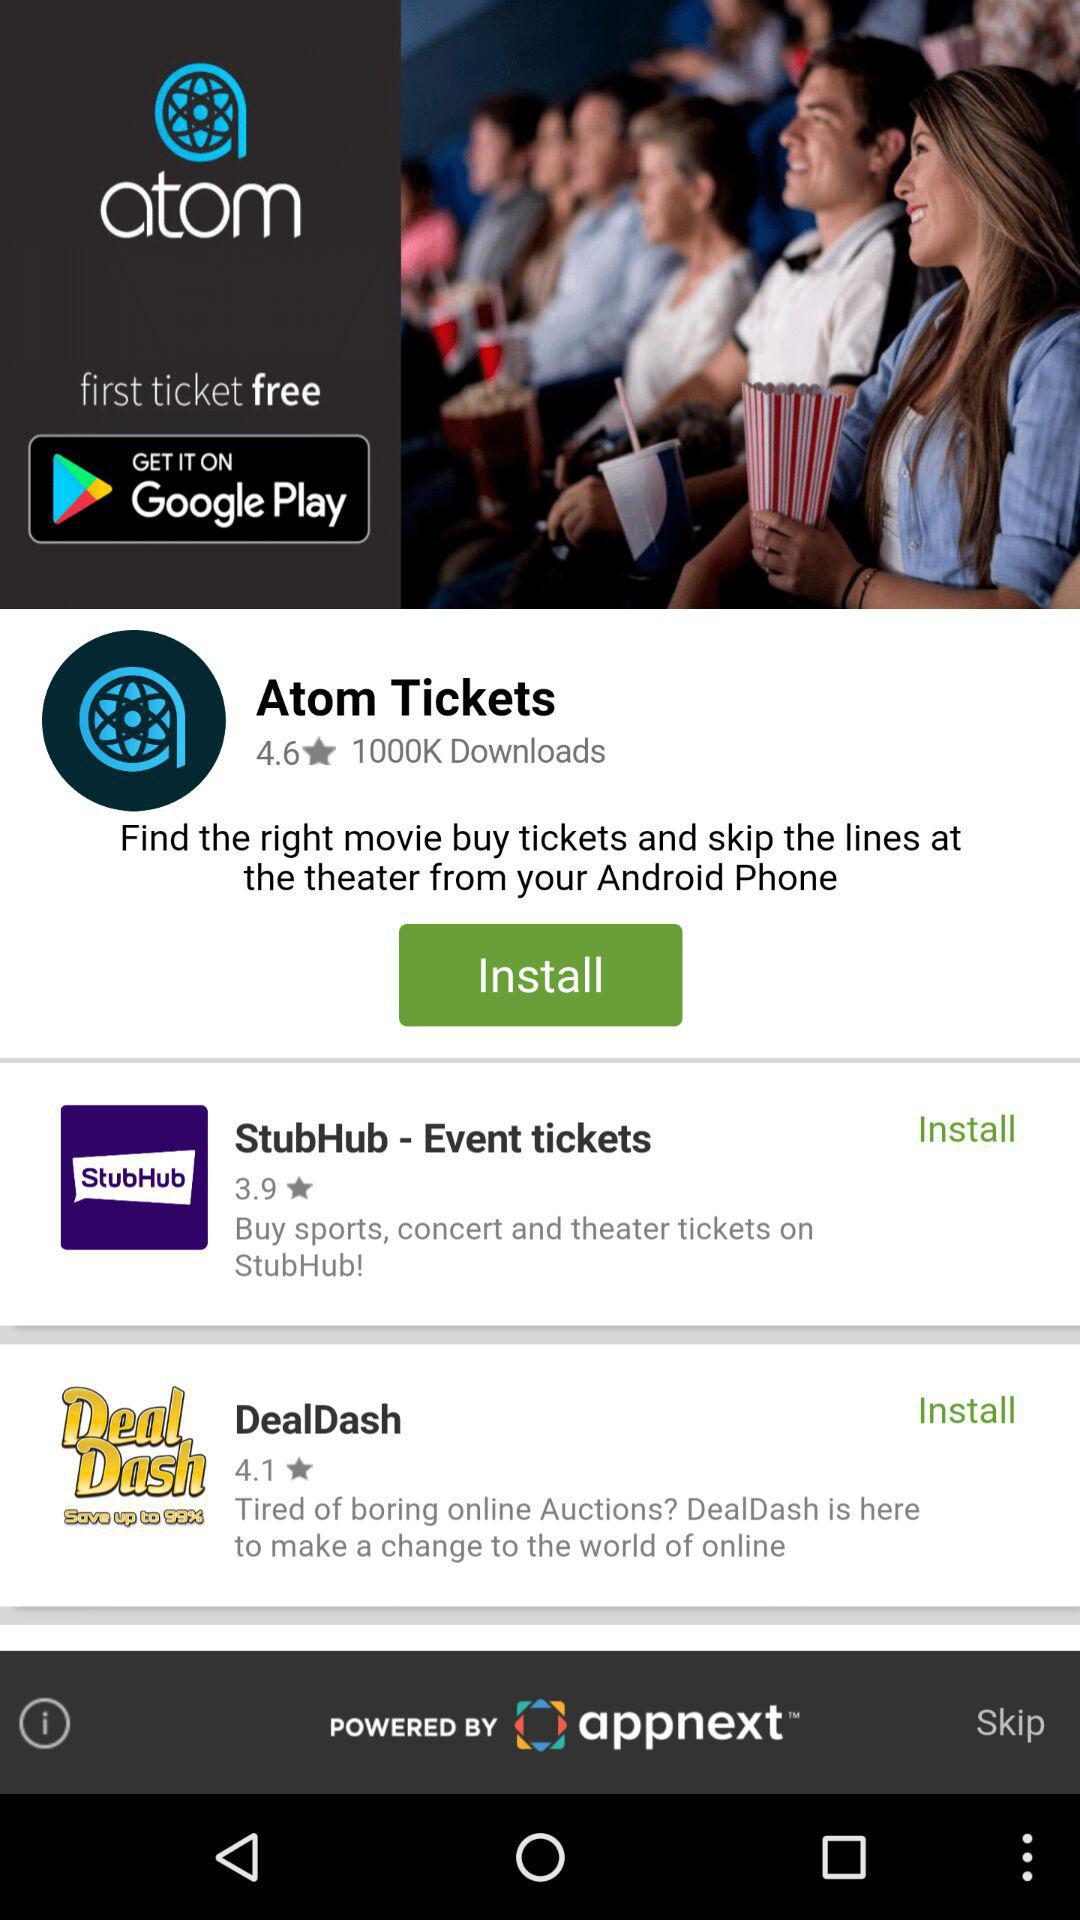Which application has a rating of 4.6? The application is "Atom Tickets". 